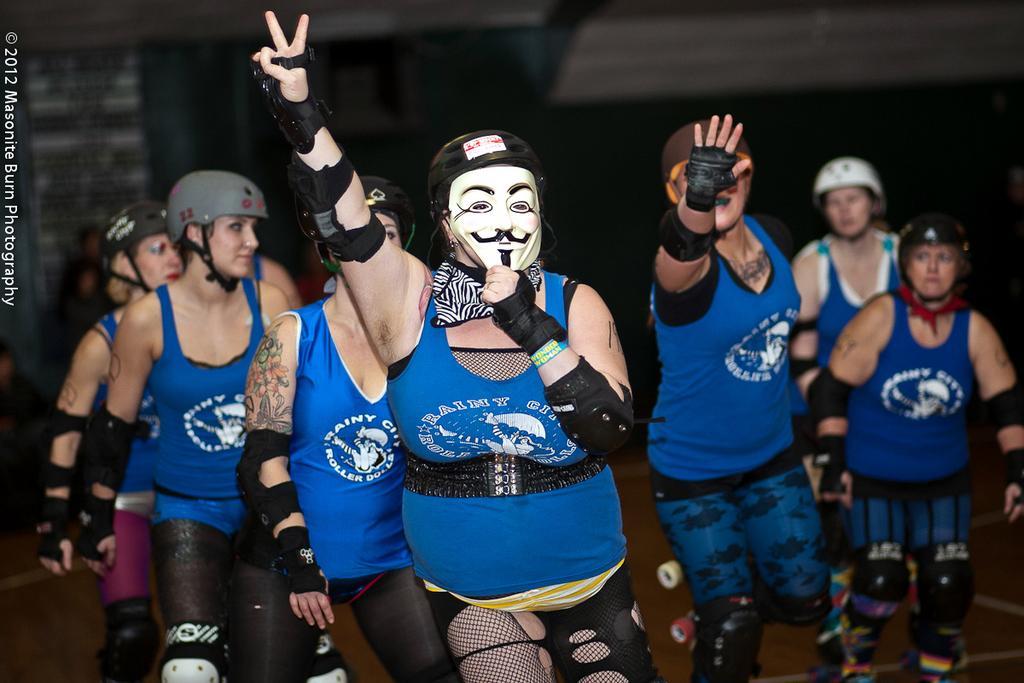Please provide a concise description of this image. Here I can see few people wearing t-shirts, helmets on their heads and walking on the ground. The person who is in the front holding a mask in the hand. The background is in black color. On the left side of the image I can see some edited text. 